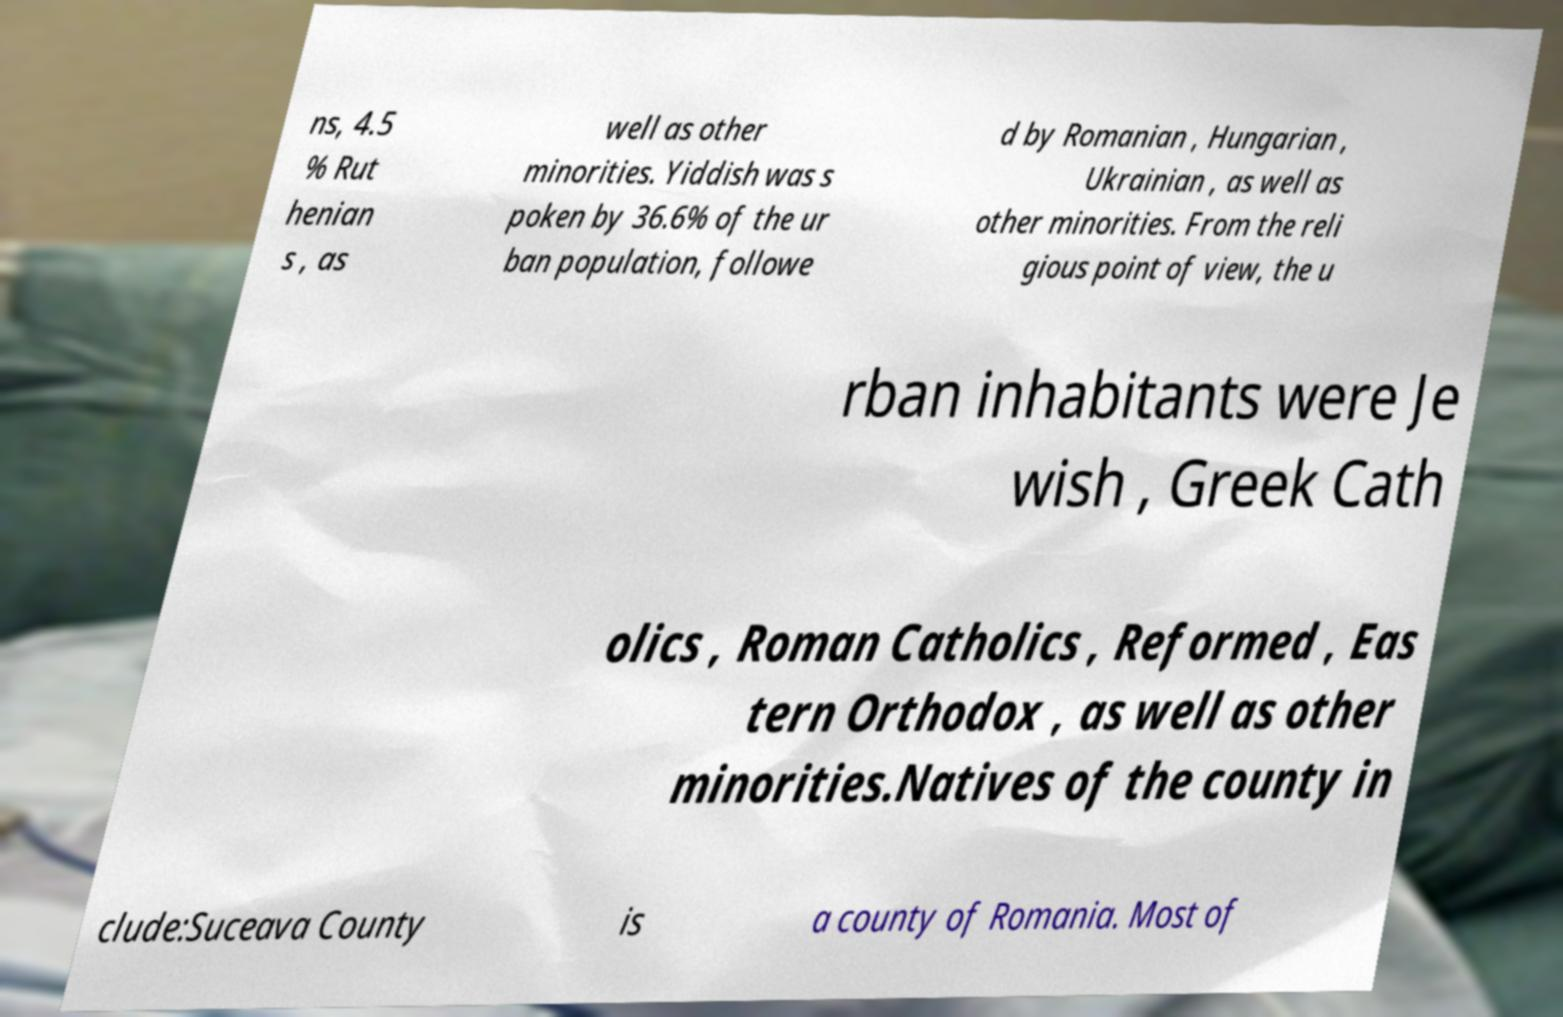Can you read and provide the text displayed in the image?This photo seems to have some interesting text. Can you extract and type it out for me? ns, 4.5 % Rut henian s , as well as other minorities. Yiddish was s poken by 36.6% of the ur ban population, followe d by Romanian , Hungarian , Ukrainian , as well as other minorities. From the reli gious point of view, the u rban inhabitants were Je wish , Greek Cath olics , Roman Catholics , Reformed , Eas tern Orthodox , as well as other minorities.Natives of the county in clude:Suceava County is a county of Romania. Most of 